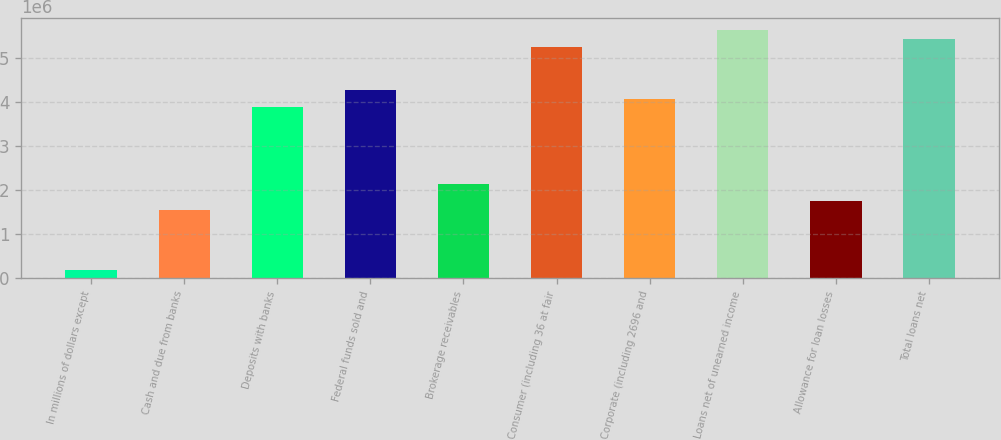Convert chart. <chart><loc_0><loc_0><loc_500><loc_500><bar_chart><fcel>In millions of dollars except<fcel>Cash and due from banks<fcel>Deposits with banks<fcel>Federal funds sold and<fcel>Brokerage receivables<fcel>Consumer (including 36 at fair<fcel>Corporate (including 2696 and<fcel>Loans net of unearned income<fcel>Allowance for loan losses<fcel>Total loans net<nl><fcel>193898<fcel>1.55079e+06<fcel>3.87688e+06<fcel>4.26457e+06<fcel>2.13231e+06<fcel>5.23377e+06<fcel>4.07072e+06<fcel>5.62145e+06<fcel>1.74463e+06<fcel>5.42761e+06<nl></chart> 